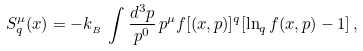Convert formula to latex. <formula><loc_0><loc_0><loc_500><loc_500>S _ { q } ^ { \mu } ( x ) = - k _ { _ { B } } \, \int \frac { d ^ { 3 } p } { p ^ { 0 } } \, p ^ { \mu } f [ ( x , p ) ] ^ { q } [ \ln _ { q } f ( x , p ) - 1 ] \, ,</formula> 